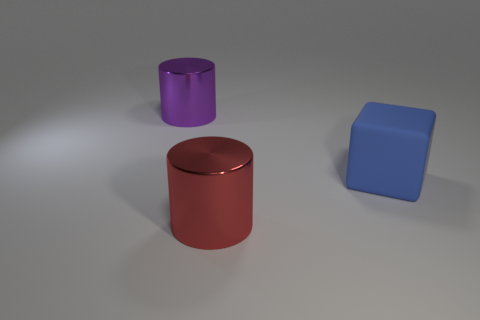Add 3 big brown rubber spheres. How many objects exist? 6 Subtract all cylinders. How many objects are left? 1 Subtract 0 purple blocks. How many objects are left? 3 Subtract all big brown matte blocks. Subtract all large purple metal cylinders. How many objects are left? 2 Add 2 large blue rubber cubes. How many large blue rubber cubes are left? 3 Add 1 large red cylinders. How many large red cylinders exist? 2 